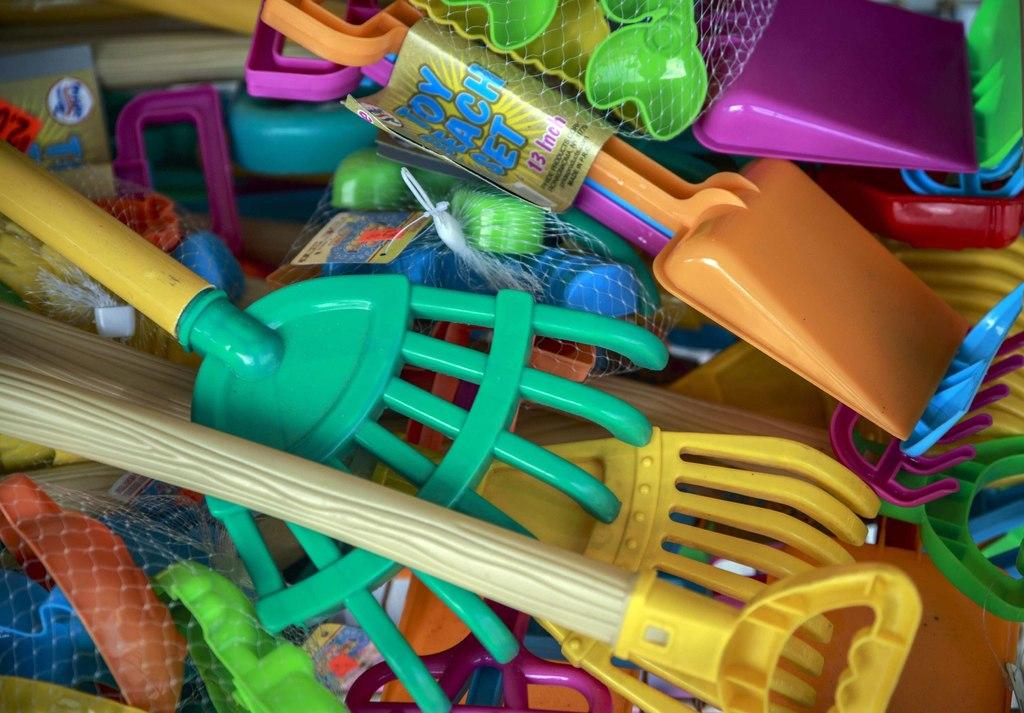What type of objects are present in the image? There is a group of plastic objects in the image. What are the nets used for in the image? The nets are not explicitly used for anything in the image, but they are present. What additional items can be seen in the image? There are tags in the image. What information is provided on the tags? There is text on the tags. Can you read the thumb on the cork in the image? There is no cork or thumb present in the image. 